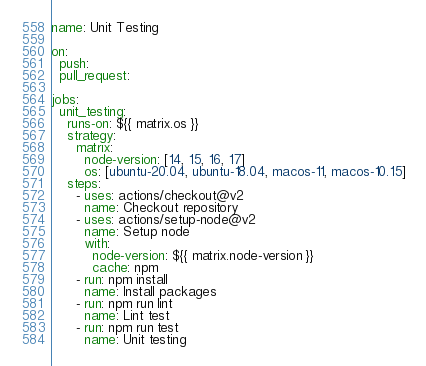Convert code to text. <code><loc_0><loc_0><loc_500><loc_500><_YAML_>name: Unit Testing

on:
  push:
  pull_request:

jobs:
  unit_testing:
    runs-on: ${{ matrix.os }}
    strategy:
      matrix:
        node-version: [14, 15, 16, 17]
        os: [ubuntu-20.04, ubuntu-18.04, macos-11, macos-10.15]
    steps:
      - uses: actions/checkout@v2
        name: Checkout repository
      - uses: actions/setup-node@v2
        name: Setup node
        with:
          node-version: ${{ matrix.node-version }}
          cache: npm
      - run: npm install
        name: Install packages
      - run: npm run lint
        name: Lint test
      - run: npm run test
        name: Unit testing
</code> 